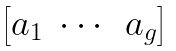Convert formula to latex. <formula><loc_0><loc_0><loc_500><loc_500>\begin{bmatrix} a _ { 1 } & \cdots & a _ { g } \end{bmatrix}</formula> 